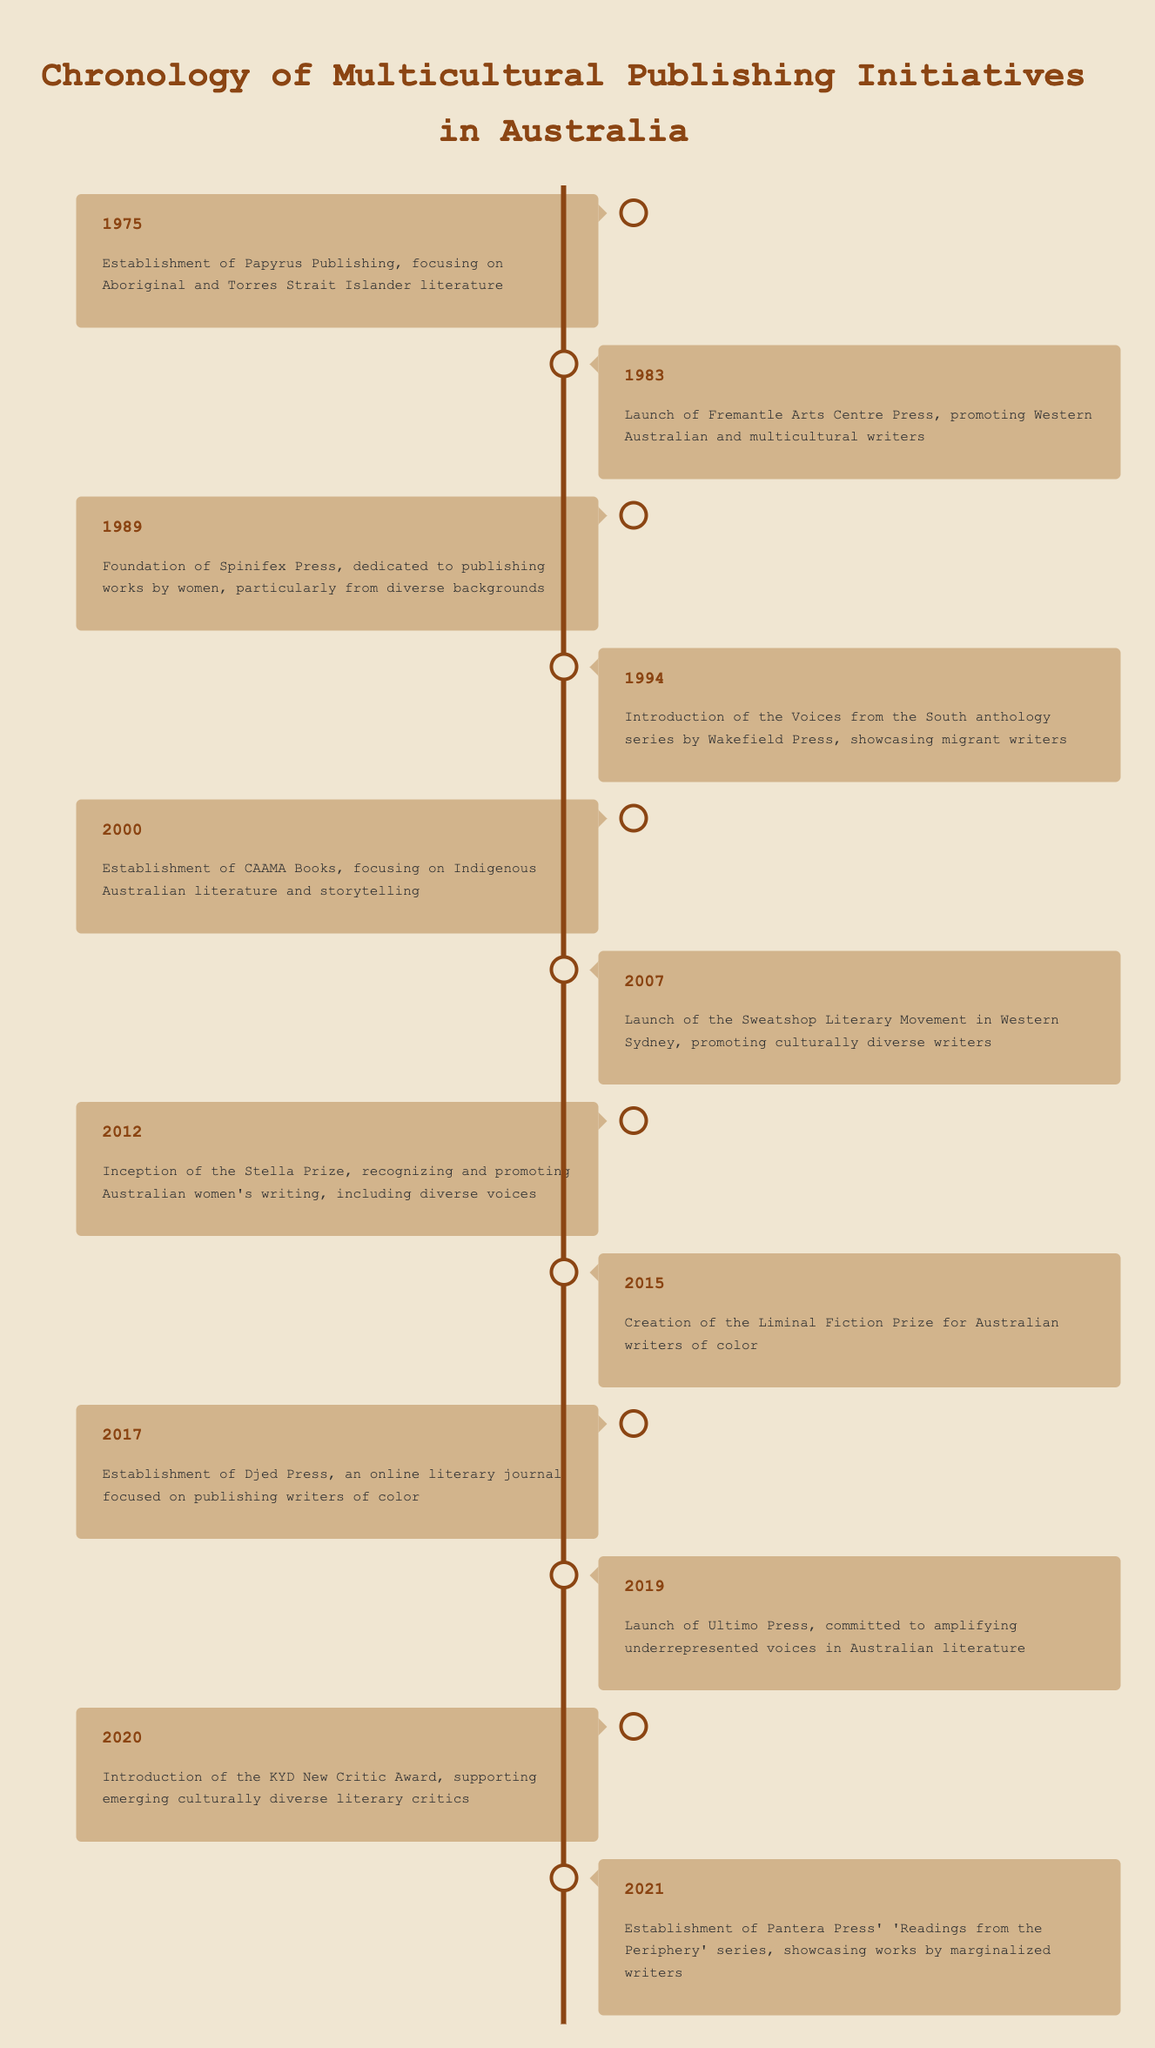What year was Papyrus Publishing established? Papyrus Publishing was established in the year 1975, as indicated in the timeline.
Answer: 1975 How many multicultural publishing initiatives occurred in the 2000s? The 2000s saw three initiatives: 2000 (CAAMA Books), 2007 (Sweatshop Literary Movement), and 2012 (Stella Prize).
Answer: 3 Was the Liminal Fiction Prize created before the Stella Prize? The Liminal Fiction Prize was created in 2015, while the Stella Prize was launched in 2012. Therefore, the Liminal Fiction Prize was created after the Stella Prize.
Answer: No Which initiative focused on Indigenous Australian literature? The establishment of CAAMA Books in 2000 specifically focused on Indigenous Australian literature and storytelling.
Answer: CAAMA Books What is the difference in years between the establishment of Djed Press and the launch of Ultimo Press? Djed Press was established in 2017 and Ultimo Press was launched in 2019. The difference between 2019 and 2017 is 2 years.
Answer: 2 years How many initiatives were dedicated to women writers? The initiatives dedicated to women writers are Spinifex Press (1989) and the Stella Prize (2012), making a total of two.
Answer: 2 True or false: The Voices from the South anthology series was introduced in 1994. The timeline clearly indicates that the Voices from the South anthology series was indeed introduced in 1994.
Answer: True How many initiatives were launched between 1989 and 2017? The initiatives launched in this timeframe are Spinifex Press (1989), the Voices from the South (1994), CAAMA Books (2000), Sweatshop Literary Movement (2007), and Djed Press (2017), totaling five initiatives.
Answer: 5 